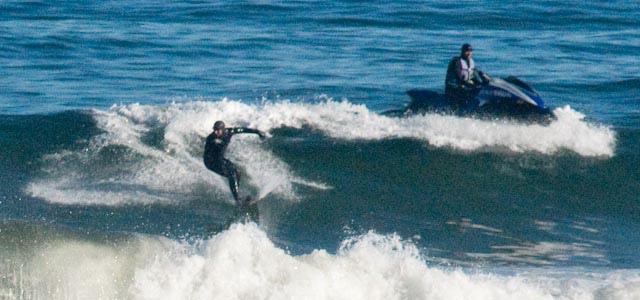What is the person on the right sitting on?
Give a very brief answer. Jet ski. Is there a boat in the water?
Concise answer only. No. Do the participants need to know how to swim?
Short answer required. Yes. 